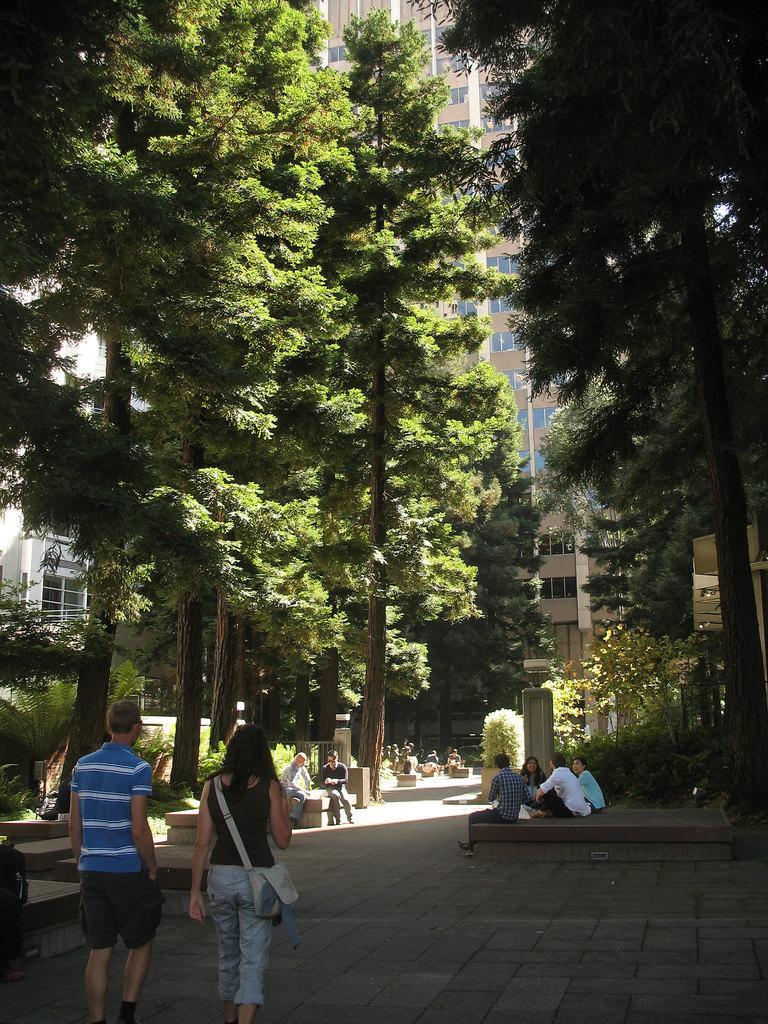How would you summarize this image in a sentence or two? In this picture we can see a few people on the path. We can see plants, trees, buildings and other objects. 